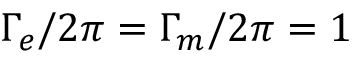<formula> <loc_0><loc_0><loc_500><loc_500>\Gamma _ { e } / 2 \pi = \Gamma _ { m } / 2 \pi = 1</formula> 